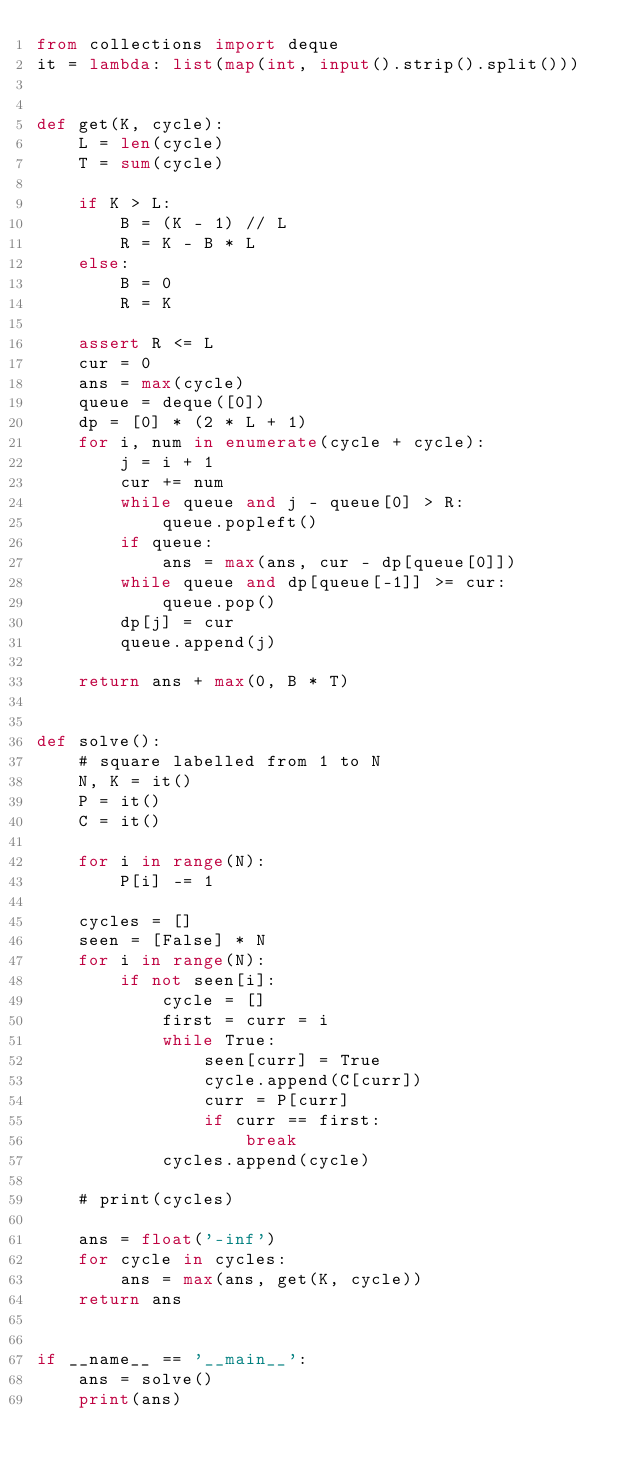<code> <loc_0><loc_0><loc_500><loc_500><_Python_>from collections import deque
it = lambda: list(map(int, input().strip().split()))


def get(K, cycle):
    L = len(cycle)
    T = sum(cycle)

    if K > L:
        B = (K - 1) // L
        R = K - B * L
    else:
        B = 0
        R = K
        
    assert R <= L
    cur = 0
    ans = max(cycle)
    queue = deque([0])
    dp = [0] * (2 * L + 1)
    for i, num in enumerate(cycle + cycle):
        j = i + 1
        cur += num
        while queue and j - queue[0] > R:
            queue.popleft()
        if queue:
            ans = max(ans, cur - dp[queue[0]])
        while queue and dp[queue[-1]] >= cur:
            queue.pop()
        dp[j] = cur
        queue.append(j)
    
    return ans + max(0, B * T)


def solve():
    # square labelled from 1 to N
    N, K = it()
    P = it()
    C = it()

    for i in range(N):
        P[i] -= 1

    cycles = []
    seen = [False] * N
    for i in range(N):
        if not seen[i]:
            cycle = []
            first = curr = i
            while True:
                seen[curr] = True
                cycle.append(C[curr])
                curr = P[curr]
                if curr == first:
                    break
            cycles.append(cycle)
    
    # print(cycles)

    ans = float('-inf')
    for cycle in cycles:
        ans = max(ans, get(K, cycle))
    return ans


if __name__ == '__main__':
    ans = solve()
    print(ans)</code> 